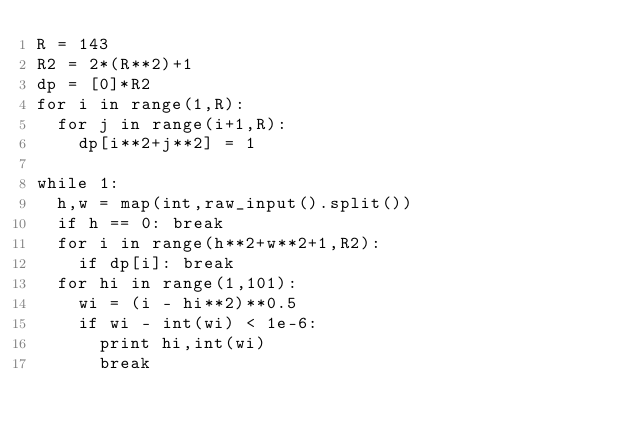Convert code to text. <code><loc_0><loc_0><loc_500><loc_500><_Python_>R = 143
R2 = 2*(R**2)+1
dp = [0]*R2
for i in range(1,R):
	for j in range(i+1,R):
		dp[i**2+j**2] = 1
	
while 1:
	h,w = map(int,raw_input().split())
	if h == 0: break
	for i in range(h**2+w**2+1,R2):
		if dp[i]: break
	for hi in range(1,101):
		wi = (i - hi**2)**0.5
		if wi - int(wi) < 1e-6:
			print hi,int(wi)
			break
	
	</code> 